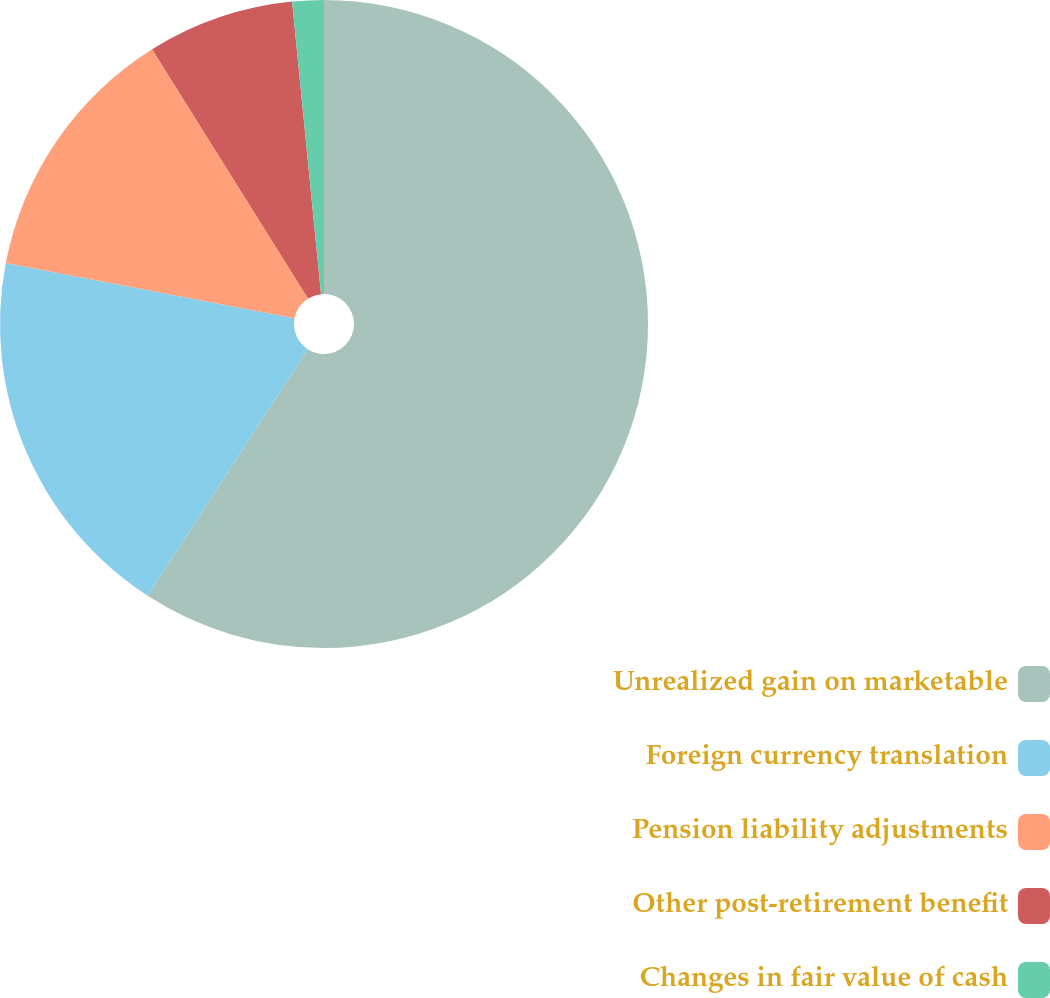Convert chart. <chart><loc_0><loc_0><loc_500><loc_500><pie_chart><fcel>Unrealized gain on marketable<fcel>Foreign currency translation<fcel>Pension liability adjustments<fcel>Other post-retirement benefit<fcel>Changes in fair value of cash<nl><fcel>59.16%<fcel>18.85%<fcel>13.09%<fcel>7.33%<fcel>1.57%<nl></chart> 